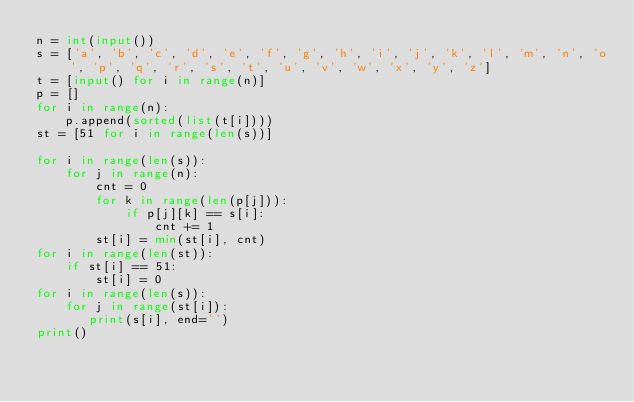<code> <loc_0><loc_0><loc_500><loc_500><_Python_>n = int(input())
s = ['a', 'b', 'c', 'd', 'e', 'f', 'g', 'h', 'i', 'j', 'k', 'l', 'm', 'n', 'o', 'p', 'q', 'r', 's', 't', 'u', 'v', 'w', 'x', 'y', 'z']
t = [input() for i in range(n)]
p = []
for i in range(n):
    p.append(sorted(list(t[i])))
st = [51 for i in range(len(s))]

for i in range(len(s)):
    for j in range(n):
        cnt = 0
        for k in range(len(p[j])):
            if p[j][k] == s[i]:
                cnt += 1
        st[i] = min(st[i], cnt)
for i in range(len(st)):
    if st[i] == 51:
        st[i] = 0
for i in range(len(s)):
    for j in range(st[i]):
       print(s[i], end='')
print()</code> 